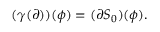<formula> <loc_0><loc_0><loc_500><loc_500>( \gamma ( \partial ) ) ( \phi ) = ( \partial S _ { 0 } ) ( \phi ) .</formula> 